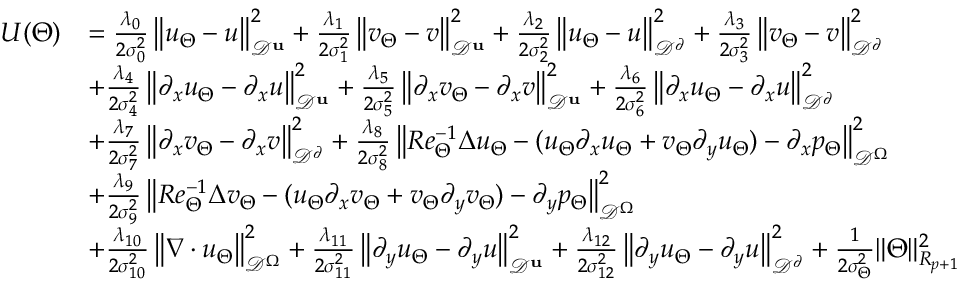<formula> <loc_0><loc_0><loc_500><loc_500>\begin{array} { r l } { U ( \Theta ) } & { = \frac { \lambda _ { 0 } } { 2 \sigma _ { 0 } ^ { 2 } } \left \| u _ { \Theta } - u \right \| _ { \mathcal { D } ^ { u } } ^ { 2 } + \frac { \lambda _ { 1 } } { 2 \sigma _ { 1 } ^ { 2 } } \left \| v _ { \Theta } - v \right \| _ { \mathcal { D } ^ { u } } ^ { 2 } + \frac { \lambda _ { 2 } } { 2 \sigma _ { 2 } ^ { 2 } } \left \| u _ { \Theta } - u \right \| _ { \mathcal { D } ^ { \partial } } ^ { 2 } + \frac { \lambda _ { 3 } } { 2 \sigma _ { 3 } ^ { 2 } } \left \| v _ { \Theta } - v \right \| _ { \mathcal { D } ^ { \partial } } ^ { 2 } } \\ & { + \frac { \lambda _ { 4 } } { 2 \sigma _ { 4 } ^ { 2 } } \left \| \partial _ { x } u _ { \Theta } - \partial _ { x } u \right \| _ { \mathcal { D } ^ { u } } ^ { 2 } + \frac { \lambda _ { 5 } } { 2 \sigma _ { 5 } ^ { 2 } } \left \| \partial _ { x } v _ { \Theta } - \partial _ { x } v \right \| _ { \mathcal { D } ^ { u } } ^ { 2 } + \frac { \lambda _ { 6 } } { 2 \sigma _ { 6 } ^ { 2 } } \left \| \partial _ { x } u _ { \Theta } - \partial _ { x } u \right \| _ { \mathcal { D } ^ { \partial } } ^ { 2 } } \\ & { + \frac { \lambda _ { 7 } } { 2 \sigma _ { 7 } ^ { 2 } } \left \| \partial _ { x } v _ { \Theta } - \partial _ { x } v \right \| _ { \mathcal { D } ^ { \partial } } ^ { 2 } + \frac { \lambda _ { 8 } } { 2 \sigma _ { 8 } ^ { 2 } } \left \| R e _ { \Theta } ^ { - 1 } \Delta u _ { \Theta } - ( u _ { \Theta } \partial _ { x } u _ { \Theta } + v _ { \Theta } \partial _ { y } u _ { \Theta } ) - \partial _ { x } p _ { \Theta } \right \| _ { \mathcal { D } ^ { \Omega } } ^ { 2 } } \\ & { + \frac { \lambda _ { 9 } } { 2 \sigma _ { 9 } ^ { 2 } } \left \| R e _ { \Theta } ^ { - 1 } \Delta v _ { \Theta } - ( u _ { \Theta } \partial _ { x } v _ { \Theta } + v _ { \Theta } \partial _ { y } v _ { \Theta } ) - \partial _ { y } p _ { \Theta } \right \| _ { \mathcal { D } ^ { \Omega } } ^ { 2 } } \\ & { + \frac { \lambda _ { 1 0 } } { 2 \sigma _ { 1 0 } ^ { 2 } } \left \| \nabla \cdot u _ { \Theta } \right \| _ { \mathcal { D } ^ { \Omega } } ^ { 2 } + \frac { \lambda _ { 1 1 } } { 2 \sigma _ { 1 1 } ^ { 2 } } \left \| \partial _ { y } u _ { \Theta } - \partial _ { y } u \right \| _ { \mathcal { D } ^ { u } } ^ { 2 } + \frac { \lambda _ { 1 2 } } { 2 \sigma _ { 1 2 } ^ { 2 } } \left \| \partial _ { y } u _ { \Theta } - \partial _ { y } u \right \| _ { \mathcal { D } ^ { \partial } } ^ { 2 } + \frac { 1 } { 2 \sigma _ { \Theta } ^ { 2 } } \| \Theta \| _ { R _ { p + 1 } } ^ { 2 } } \end{array}</formula> 